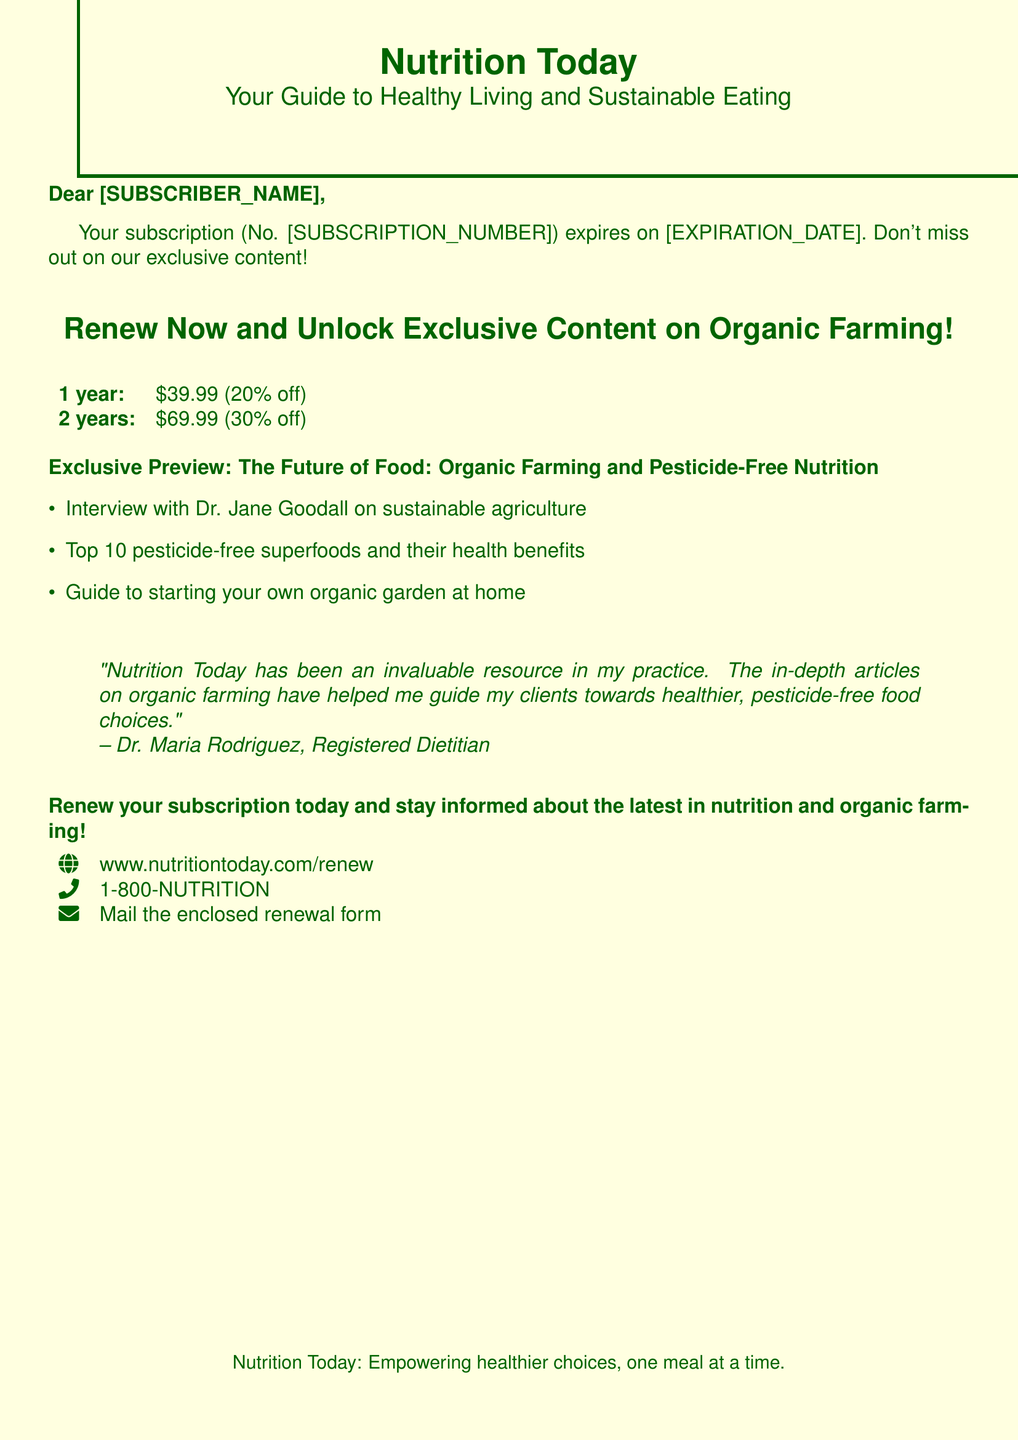What is the name of the magazine? The document identifies the magazine as "Nutrition Today."
Answer: Nutrition Today What is the tagline of the magazine? The tagline provided is "Your Guide to Healthy Living and Sustainable Eating."
Answer: Your Guide to Healthy Living and Sustainable Eating What is the expiration date of the subscription? The document placeholder shows "[EXPIRATION_DATE]," which will be filled for the subscriber.
Answer: [EXPIRATION_DATE] What discount is offered for a 2-year renewal? The document states that there is a 30% discount for the 2-year option.
Answer: 30% off Who is interviewed in the exclusive content preview? The document mentions Dr. Jane Goodall in the exclusive content preview.
Answer: Dr. Jane Goodall What is the price for a 1-year renewal? The renewal offer states that the price for a 1-year subscription is $39.99.
Answer: $39.99 What is one of the highlights of the exclusive content? The document lists several highlights, one of which is the interview with Dr. Jane Goodall.
Answer: Interview with Dr. Jane Goodall on sustainable agriculture Who provided a testimonial about the magazine? The testimonial in the document is attributed to Dr. Maria Rodriguez.
Answer: Dr. Maria Rodriguez What is the online renewal website? The document provides the website as www.nutritiontoday.com/renew.
Answer: www.nutritiontoday.com/renew 